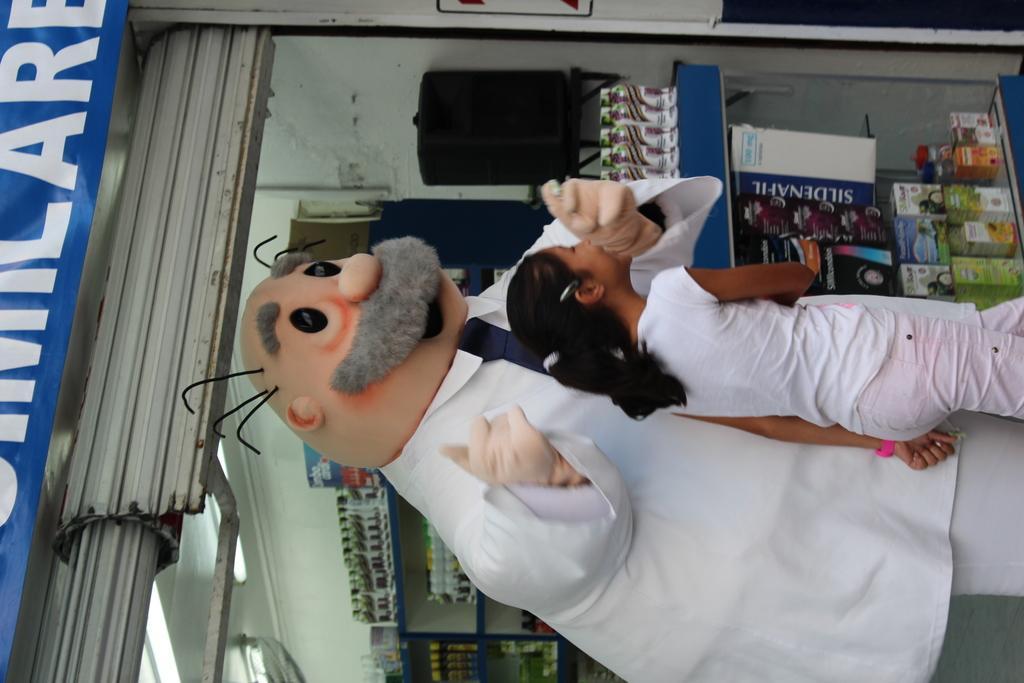In one or two sentences, can you explain what this image depicts? In this image in front there are two persons. Behind them there are objects on the shelf's. In the background of the image there is a wall. On top of the image there is a light. There is a shutter. 